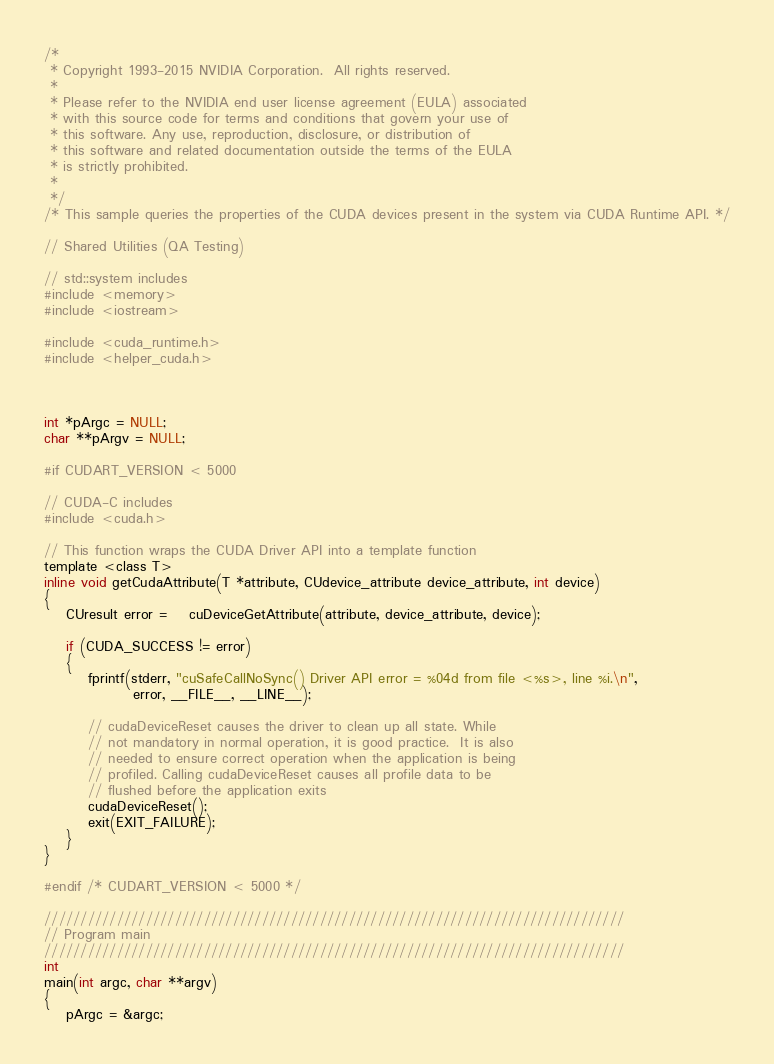Convert code to text. <code><loc_0><loc_0><loc_500><loc_500><_Cuda_>/*
 * Copyright 1993-2015 NVIDIA Corporation.  All rights reserved.
 *
 * Please refer to the NVIDIA end user license agreement (EULA) associated
 * with this source code for terms and conditions that govern your use of
 * this software. Any use, reproduction, disclosure, or distribution of
 * this software and related documentation outside the terms of the EULA
 * is strictly prohibited.
 *
 */
/* This sample queries the properties of the CUDA devices present in the system via CUDA Runtime API. */

// Shared Utilities (QA Testing)

// std::system includes
#include <memory>
#include <iostream>

#include <cuda_runtime.h>
#include <helper_cuda.h>



int *pArgc = NULL;
char **pArgv = NULL;

#if CUDART_VERSION < 5000

// CUDA-C includes
#include <cuda.h>

// This function wraps the CUDA Driver API into a template function
template <class T>
inline void getCudaAttribute(T *attribute, CUdevice_attribute device_attribute, int device)
{
    CUresult error =    cuDeviceGetAttribute(attribute, device_attribute, device);

    if (CUDA_SUCCESS != error)
    {
        fprintf(stderr, "cuSafeCallNoSync() Driver API error = %04d from file <%s>, line %i.\n",
                error, __FILE__, __LINE__);

        // cudaDeviceReset causes the driver to clean up all state. While
        // not mandatory in normal operation, it is good practice.  It is also
        // needed to ensure correct operation when the application is being
        // profiled. Calling cudaDeviceReset causes all profile data to be
        // flushed before the application exits
        cudaDeviceReset();
        exit(EXIT_FAILURE);
    }
}

#endif /* CUDART_VERSION < 5000 */

////////////////////////////////////////////////////////////////////////////////
// Program main
////////////////////////////////////////////////////////////////////////////////
int
main(int argc, char **argv)
{
    pArgc = &argc;</code> 